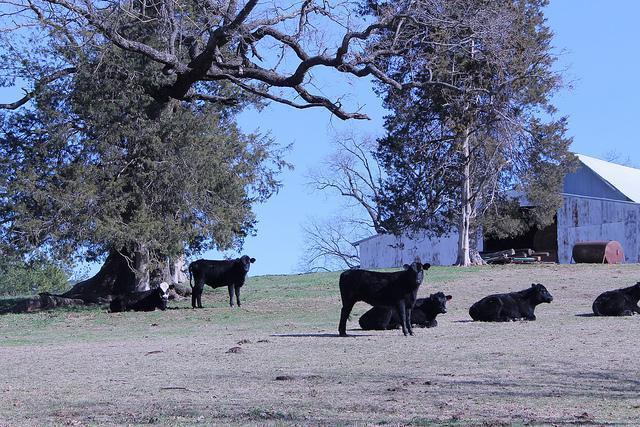How many cows are there?
Give a very brief answer. 6. How many cows are standing?
Give a very brief answer. 2. 